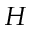Convert formula to latex. <formula><loc_0><loc_0><loc_500><loc_500>H</formula> 